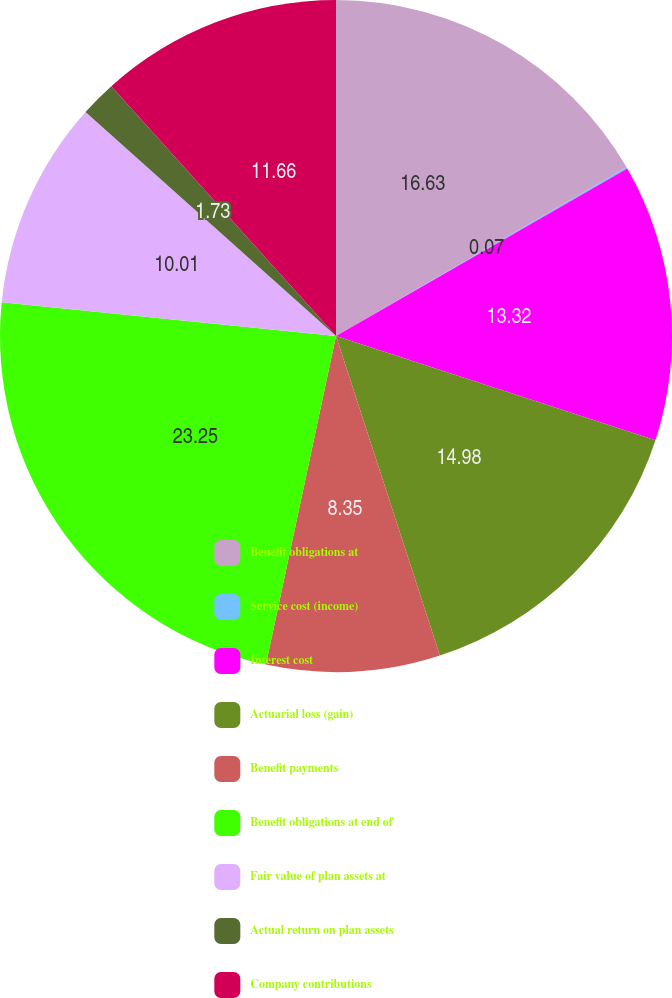<chart> <loc_0><loc_0><loc_500><loc_500><pie_chart><fcel>Benefit obligations at<fcel>Service cost (income)<fcel>Interest cost<fcel>Actuarial loss (gain)<fcel>Benefit payments<fcel>Benefit obligations at end of<fcel>Fair value of plan assets at<fcel>Actual return on plan assets<fcel>Company contributions<nl><fcel>16.63%<fcel>0.07%<fcel>13.32%<fcel>14.98%<fcel>8.35%<fcel>23.26%<fcel>10.01%<fcel>1.73%<fcel>11.66%<nl></chart> 